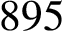<formula> <loc_0><loc_0><loc_500><loc_500>8 9 5</formula> 